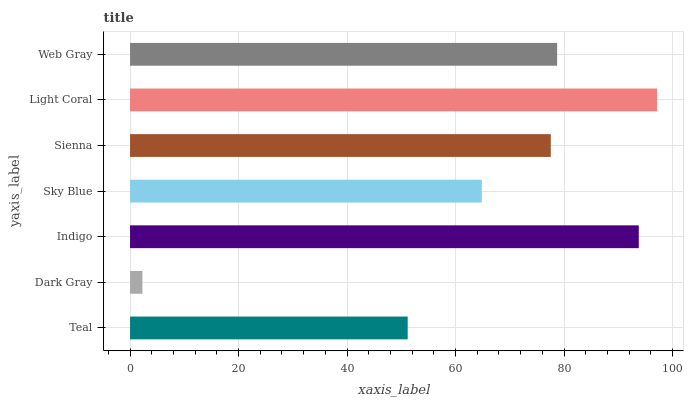Is Dark Gray the minimum?
Answer yes or no. Yes. Is Light Coral the maximum?
Answer yes or no. Yes. Is Indigo the minimum?
Answer yes or no. No. Is Indigo the maximum?
Answer yes or no. No. Is Indigo greater than Dark Gray?
Answer yes or no. Yes. Is Dark Gray less than Indigo?
Answer yes or no. Yes. Is Dark Gray greater than Indigo?
Answer yes or no. No. Is Indigo less than Dark Gray?
Answer yes or no. No. Is Sienna the high median?
Answer yes or no. Yes. Is Sienna the low median?
Answer yes or no. Yes. Is Web Gray the high median?
Answer yes or no. No. Is Dark Gray the low median?
Answer yes or no. No. 